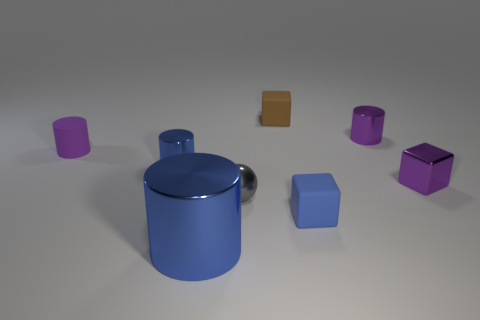Subtract 1 cylinders. How many cylinders are left? 3 Subtract all large blue metallic cylinders. How many cylinders are left? 3 Add 1 tiny purple metal things. How many objects exist? 9 Subtract all brown cylinders. Subtract all blue cubes. How many cylinders are left? 4 Subtract all cubes. How many objects are left? 5 Subtract 1 purple cubes. How many objects are left? 7 Subtract all brown matte blocks. Subtract all purple things. How many objects are left? 4 Add 2 small blue blocks. How many small blue blocks are left? 3 Add 4 blue cylinders. How many blue cylinders exist? 6 